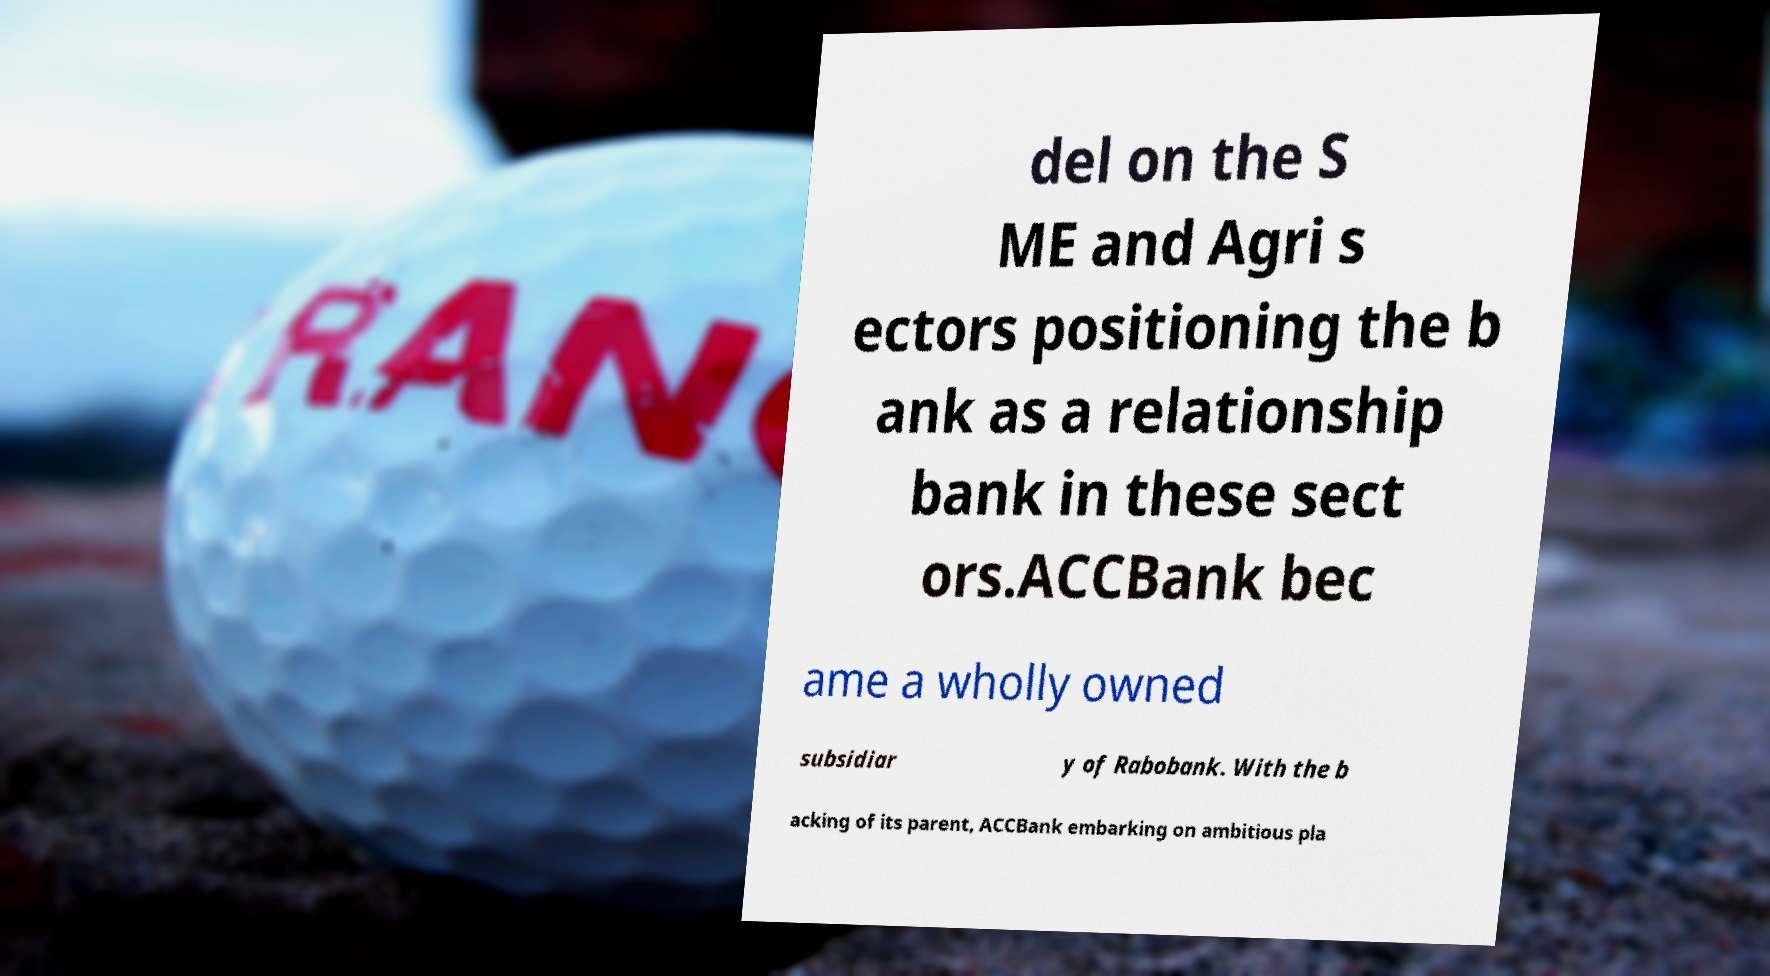Please read and relay the text visible in this image. What does it say? del on the S ME and Agri s ectors positioning the b ank as a relationship bank in these sect ors.ACCBank bec ame a wholly owned subsidiar y of Rabobank. With the b acking of its parent, ACCBank embarking on ambitious pla 